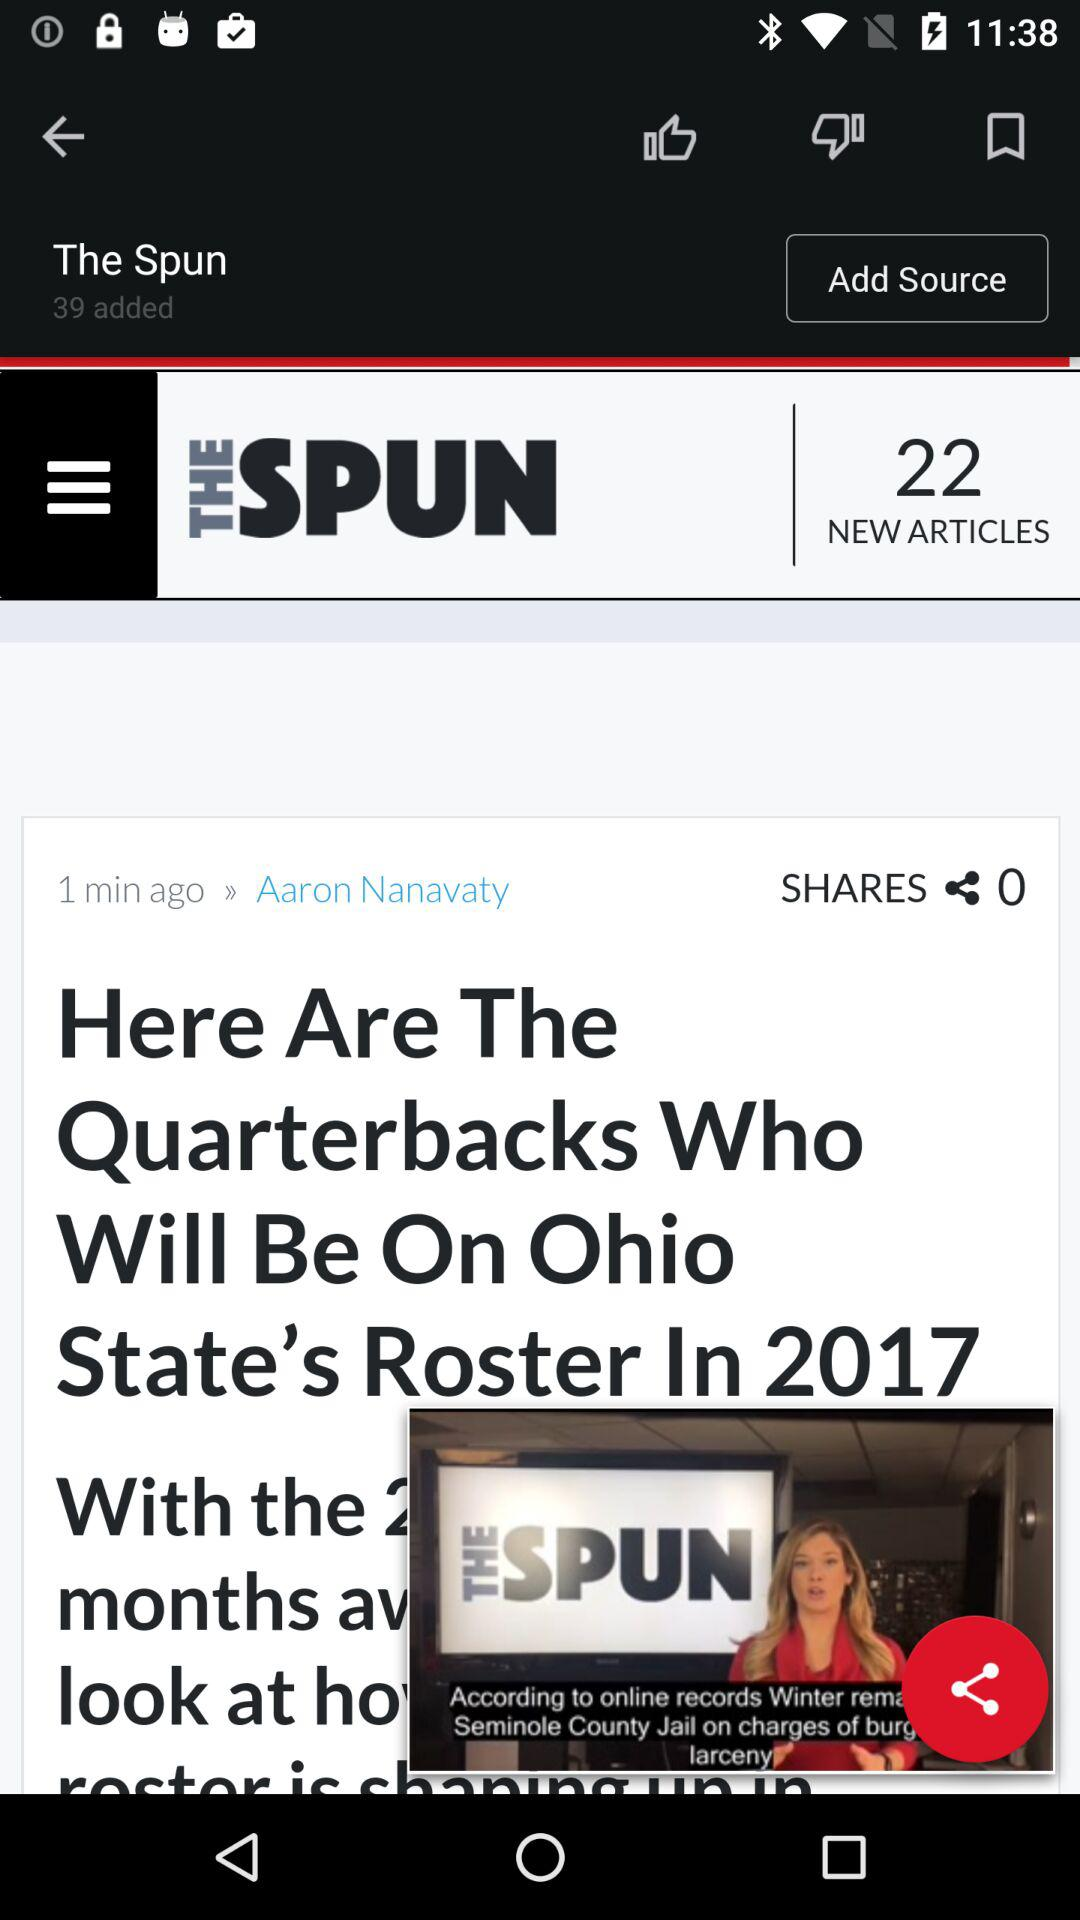How many times has this article been shared? The article has been shared 0 times. 